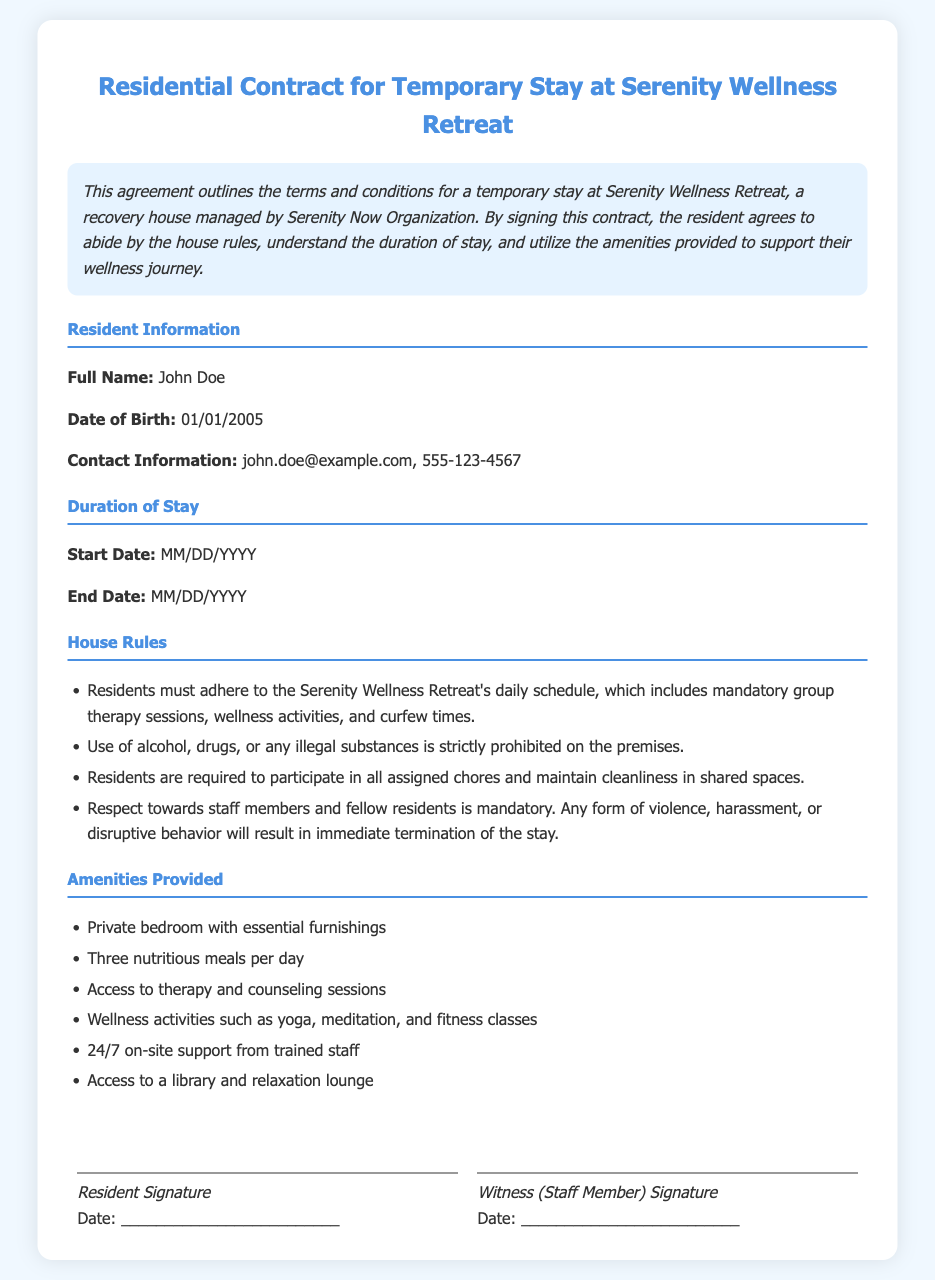what is the name of the retreat? The retreat is referred to as Serenity Wellness Retreat in the document title.
Answer: Serenity Wellness Retreat who is the resident mentioned in the document? The document provides specific information about the resident's full name.
Answer: John Doe what is the start date of the stay? The contract specifies a placeholder for the start date, indicating it will be filled in later.
Answer: MM/DD/YYYY is alcohol allowed on the premises? The house rules explicitly state the prohibition of alcohol within the retreat.
Answer: No how many meals are provided per day? The amenities section states the number of meals residents receive each day.
Answer: Three what kind of activities are included during the stay? The amenities section lists wellness activities available to residents at the retreat.
Answer: yoga, meditation, and fitness classes what is one requirement for residents regarding cleanliness? One of the house rules mentions responsibilities related to maintaining common areas.
Answer: Participate in all assigned chores who signs as the witness for the resident? The document states a staff member will sign as a witness, but does not specify a name.
Answer: Staff Member what will happen if a resident shows violence? The house rules outline the consequences for violent behavior.
Answer: Immediate termination of the stay 